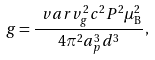Convert formula to latex. <formula><loc_0><loc_0><loc_500><loc_500>g = \frac { \ v a r v _ { g } ^ { 2 } c ^ { 2 } P ^ { 2 } \mu _ { \mathrm B } ^ { 2 } } { 4 \pi ^ { 2 } a _ { p } ^ { 3 } d ^ { 3 } } ,</formula> 